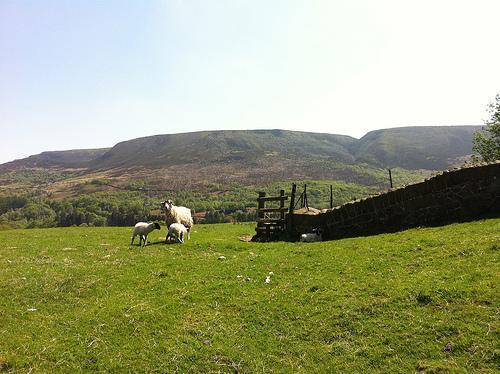How many sheep are near the camera?
Give a very brief answer. 0. 